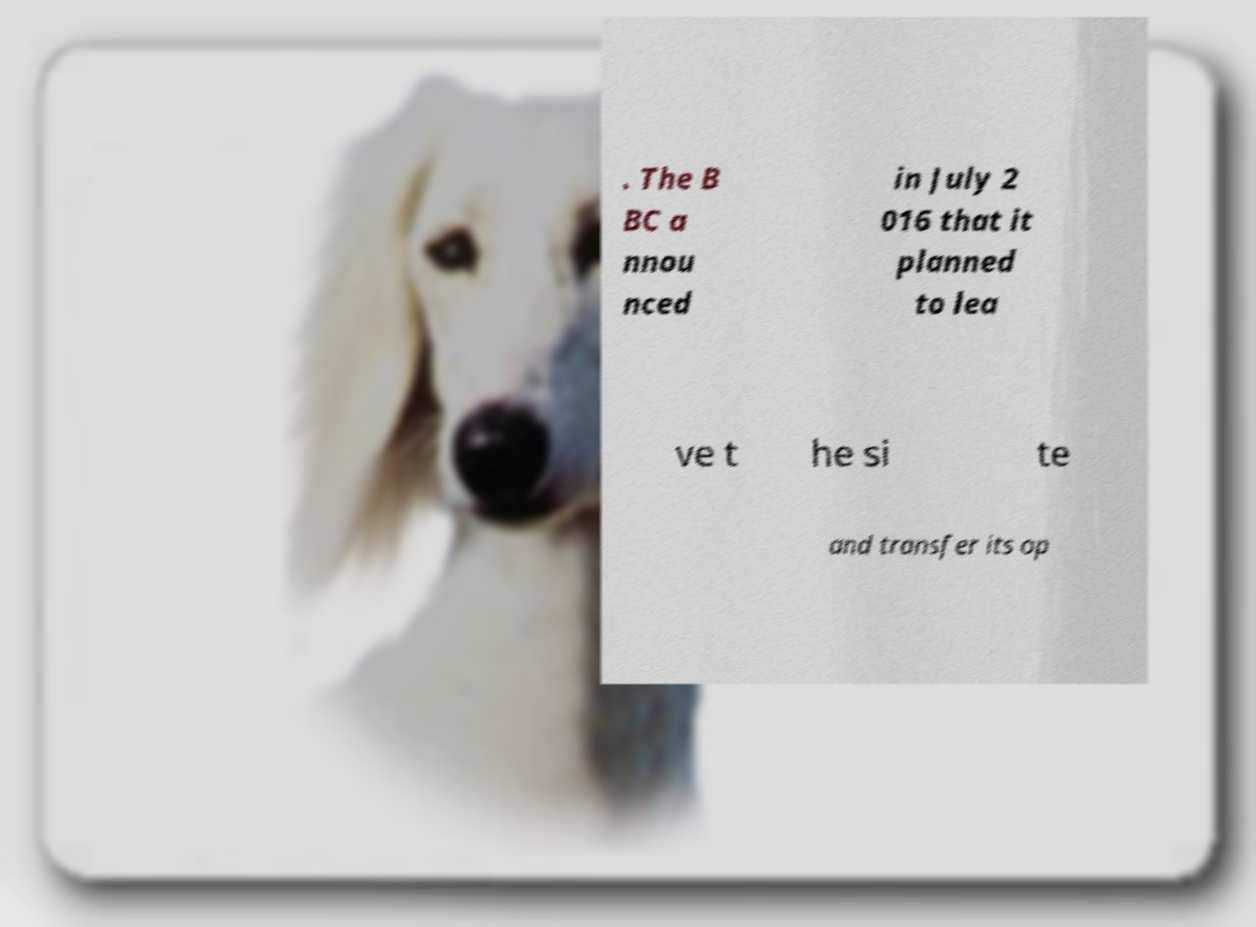Please identify and transcribe the text found in this image. . The B BC a nnou nced in July 2 016 that it planned to lea ve t he si te and transfer its op 